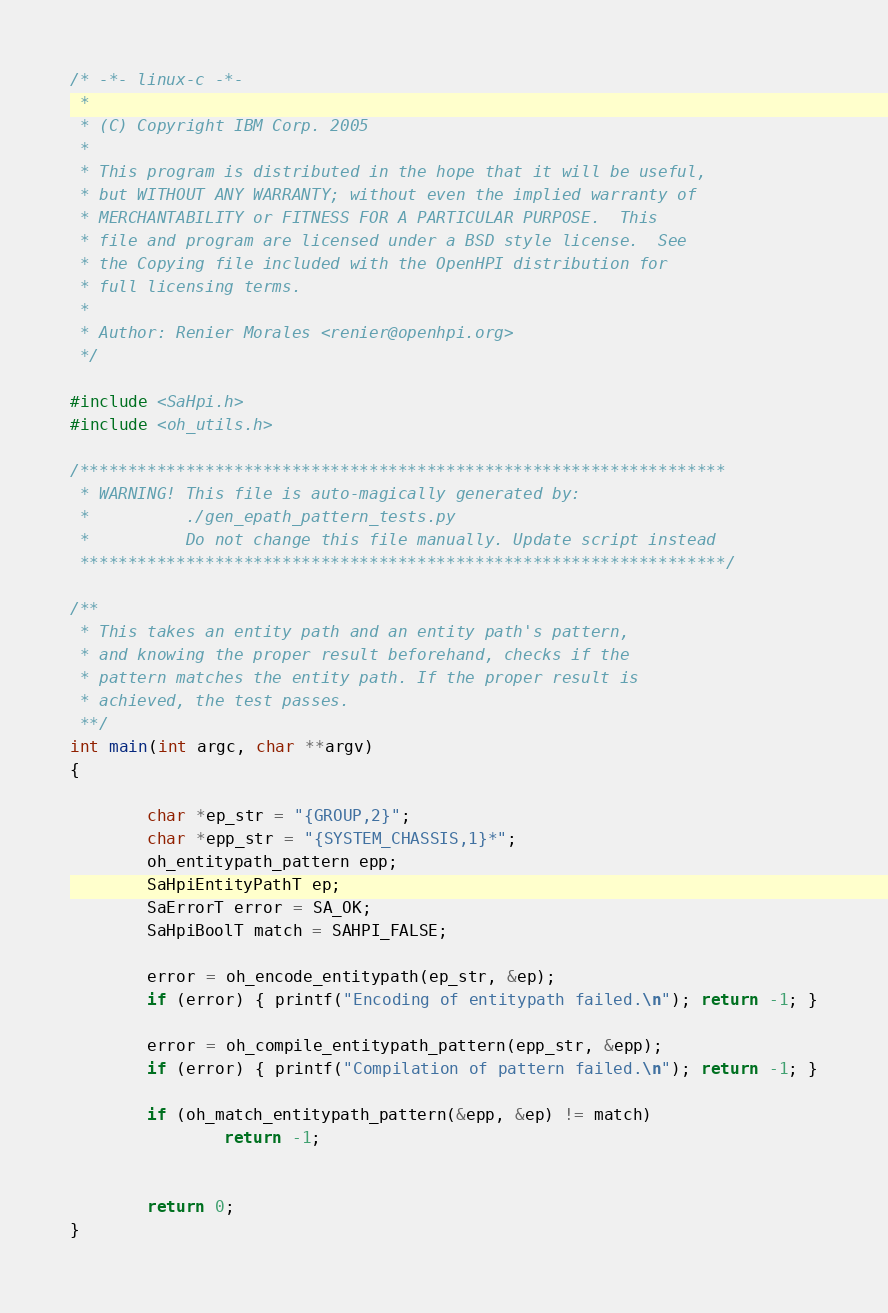Convert code to text. <code><loc_0><loc_0><loc_500><loc_500><_C_>/* -*- linux-c -*-
 *
 * (C) Copyright IBM Corp. 2005
 *
 * This program is distributed in the hope that it will be useful,
 * but WITHOUT ANY WARRANTY; without even the implied warranty of
 * MERCHANTABILITY or FITNESS FOR A PARTICULAR PURPOSE.  This
 * file and program are licensed under a BSD style license.  See
 * the Copying file included with the OpenHPI distribution for
 * full licensing terms.
 *
 * Author: Renier Morales <renier@openhpi.org>
 */

#include <SaHpi.h>
#include <oh_utils.h>

/*******************************************************************
 * WARNING! This file is auto-magically generated by:
 *          ./gen_epath_pattern_tests.py
 *          Do not change this file manually. Update script instead
 *******************************************************************/

/**
 * This takes an entity path and an entity path's pattern,
 * and knowing the proper result beforehand, checks if the
 * pattern matches the entity path. If the proper result is
 * achieved, the test passes.
 **/
int main(int argc, char **argv)
{

        char *ep_str = "{GROUP,2}";
        char *epp_str = "{SYSTEM_CHASSIS,1}*";
        oh_entitypath_pattern epp;
        SaHpiEntityPathT ep;
        SaErrorT error = SA_OK;
        SaHpiBoolT match = SAHPI_FALSE;

        error = oh_encode_entitypath(ep_str, &ep);
        if (error) { printf("Encoding of entitypath failed.\n"); return -1; }

        error = oh_compile_entitypath_pattern(epp_str, &epp);
        if (error) { printf("Compilation of pattern failed.\n"); return -1; }

        if (oh_match_entitypath_pattern(&epp, &ep) != match)
                return -1;
        

        return 0;
}

</code> 